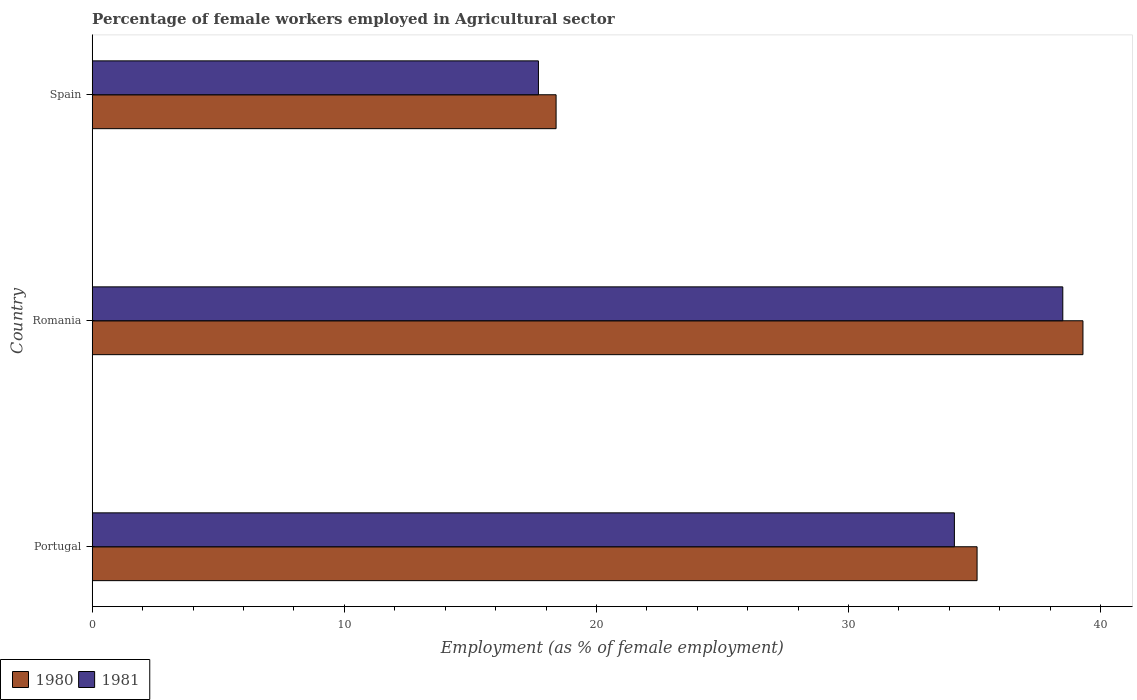How many groups of bars are there?
Make the answer very short. 3. Are the number of bars per tick equal to the number of legend labels?
Give a very brief answer. Yes. How many bars are there on the 1st tick from the top?
Your answer should be compact. 2. How many bars are there on the 1st tick from the bottom?
Give a very brief answer. 2. What is the label of the 3rd group of bars from the top?
Your answer should be compact. Portugal. In how many cases, is the number of bars for a given country not equal to the number of legend labels?
Offer a terse response. 0. What is the percentage of females employed in Agricultural sector in 1980 in Portugal?
Provide a succinct answer. 35.1. Across all countries, what is the maximum percentage of females employed in Agricultural sector in 1981?
Give a very brief answer. 38.5. Across all countries, what is the minimum percentage of females employed in Agricultural sector in 1980?
Offer a terse response. 18.4. In which country was the percentage of females employed in Agricultural sector in 1980 maximum?
Give a very brief answer. Romania. In which country was the percentage of females employed in Agricultural sector in 1980 minimum?
Make the answer very short. Spain. What is the total percentage of females employed in Agricultural sector in 1981 in the graph?
Give a very brief answer. 90.4. What is the difference between the percentage of females employed in Agricultural sector in 1981 in Romania and that in Spain?
Provide a succinct answer. 20.8. What is the difference between the percentage of females employed in Agricultural sector in 1980 in Spain and the percentage of females employed in Agricultural sector in 1981 in Romania?
Your response must be concise. -20.1. What is the average percentage of females employed in Agricultural sector in 1980 per country?
Offer a very short reply. 30.93. What is the difference between the percentage of females employed in Agricultural sector in 1981 and percentage of females employed in Agricultural sector in 1980 in Spain?
Make the answer very short. -0.7. What is the ratio of the percentage of females employed in Agricultural sector in 1980 in Portugal to that in Romania?
Ensure brevity in your answer.  0.89. Is the percentage of females employed in Agricultural sector in 1981 in Portugal less than that in Spain?
Provide a succinct answer. No. Is the difference between the percentage of females employed in Agricultural sector in 1981 in Romania and Spain greater than the difference between the percentage of females employed in Agricultural sector in 1980 in Romania and Spain?
Ensure brevity in your answer.  No. What is the difference between the highest and the second highest percentage of females employed in Agricultural sector in 1980?
Offer a terse response. 4.2. What is the difference between the highest and the lowest percentage of females employed in Agricultural sector in 1981?
Your answer should be compact. 20.8. In how many countries, is the percentage of females employed in Agricultural sector in 1981 greater than the average percentage of females employed in Agricultural sector in 1981 taken over all countries?
Your response must be concise. 2. Is the sum of the percentage of females employed in Agricultural sector in 1980 in Portugal and Romania greater than the maximum percentage of females employed in Agricultural sector in 1981 across all countries?
Give a very brief answer. Yes. What does the 1st bar from the bottom in Romania represents?
Ensure brevity in your answer.  1980. How many bars are there?
Ensure brevity in your answer.  6. Are all the bars in the graph horizontal?
Your response must be concise. Yes. How many countries are there in the graph?
Make the answer very short. 3. What is the difference between two consecutive major ticks on the X-axis?
Offer a terse response. 10. Does the graph contain any zero values?
Give a very brief answer. No. Does the graph contain grids?
Your response must be concise. No. How are the legend labels stacked?
Make the answer very short. Horizontal. What is the title of the graph?
Provide a succinct answer. Percentage of female workers employed in Agricultural sector. Does "1990" appear as one of the legend labels in the graph?
Provide a short and direct response. No. What is the label or title of the X-axis?
Offer a very short reply. Employment (as % of female employment). What is the Employment (as % of female employment) of 1980 in Portugal?
Make the answer very short. 35.1. What is the Employment (as % of female employment) in 1981 in Portugal?
Your response must be concise. 34.2. What is the Employment (as % of female employment) in 1980 in Romania?
Make the answer very short. 39.3. What is the Employment (as % of female employment) in 1981 in Romania?
Provide a short and direct response. 38.5. What is the Employment (as % of female employment) in 1980 in Spain?
Ensure brevity in your answer.  18.4. What is the Employment (as % of female employment) in 1981 in Spain?
Make the answer very short. 17.7. Across all countries, what is the maximum Employment (as % of female employment) of 1980?
Ensure brevity in your answer.  39.3. Across all countries, what is the maximum Employment (as % of female employment) in 1981?
Keep it short and to the point. 38.5. Across all countries, what is the minimum Employment (as % of female employment) in 1980?
Your answer should be compact. 18.4. Across all countries, what is the minimum Employment (as % of female employment) of 1981?
Give a very brief answer. 17.7. What is the total Employment (as % of female employment) of 1980 in the graph?
Keep it short and to the point. 92.8. What is the total Employment (as % of female employment) of 1981 in the graph?
Your answer should be compact. 90.4. What is the difference between the Employment (as % of female employment) of 1981 in Portugal and that in Romania?
Your answer should be compact. -4.3. What is the difference between the Employment (as % of female employment) of 1980 in Romania and that in Spain?
Give a very brief answer. 20.9. What is the difference between the Employment (as % of female employment) of 1981 in Romania and that in Spain?
Make the answer very short. 20.8. What is the difference between the Employment (as % of female employment) of 1980 in Portugal and the Employment (as % of female employment) of 1981 in Spain?
Offer a terse response. 17.4. What is the difference between the Employment (as % of female employment) of 1980 in Romania and the Employment (as % of female employment) of 1981 in Spain?
Your response must be concise. 21.6. What is the average Employment (as % of female employment) of 1980 per country?
Offer a terse response. 30.93. What is the average Employment (as % of female employment) in 1981 per country?
Keep it short and to the point. 30.13. What is the difference between the Employment (as % of female employment) in 1980 and Employment (as % of female employment) in 1981 in Spain?
Your response must be concise. 0.7. What is the ratio of the Employment (as % of female employment) of 1980 in Portugal to that in Romania?
Give a very brief answer. 0.89. What is the ratio of the Employment (as % of female employment) of 1981 in Portugal to that in Romania?
Offer a very short reply. 0.89. What is the ratio of the Employment (as % of female employment) in 1980 in Portugal to that in Spain?
Give a very brief answer. 1.91. What is the ratio of the Employment (as % of female employment) in 1981 in Portugal to that in Spain?
Offer a terse response. 1.93. What is the ratio of the Employment (as % of female employment) in 1980 in Romania to that in Spain?
Keep it short and to the point. 2.14. What is the ratio of the Employment (as % of female employment) of 1981 in Romania to that in Spain?
Your answer should be compact. 2.18. What is the difference between the highest and the second highest Employment (as % of female employment) of 1980?
Make the answer very short. 4.2. What is the difference between the highest and the second highest Employment (as % of female employment) of 1981?
Ensure brevity in your answer.  4.3. What is the difference between the highest and the lowest Employment (as % of female employment) of 1980?
Your answer should be very brief. 20.9. What is the difference between the highest and the lowest Employment (as % of female employment) in 1981?
Give a very brief answer. 20.8. 